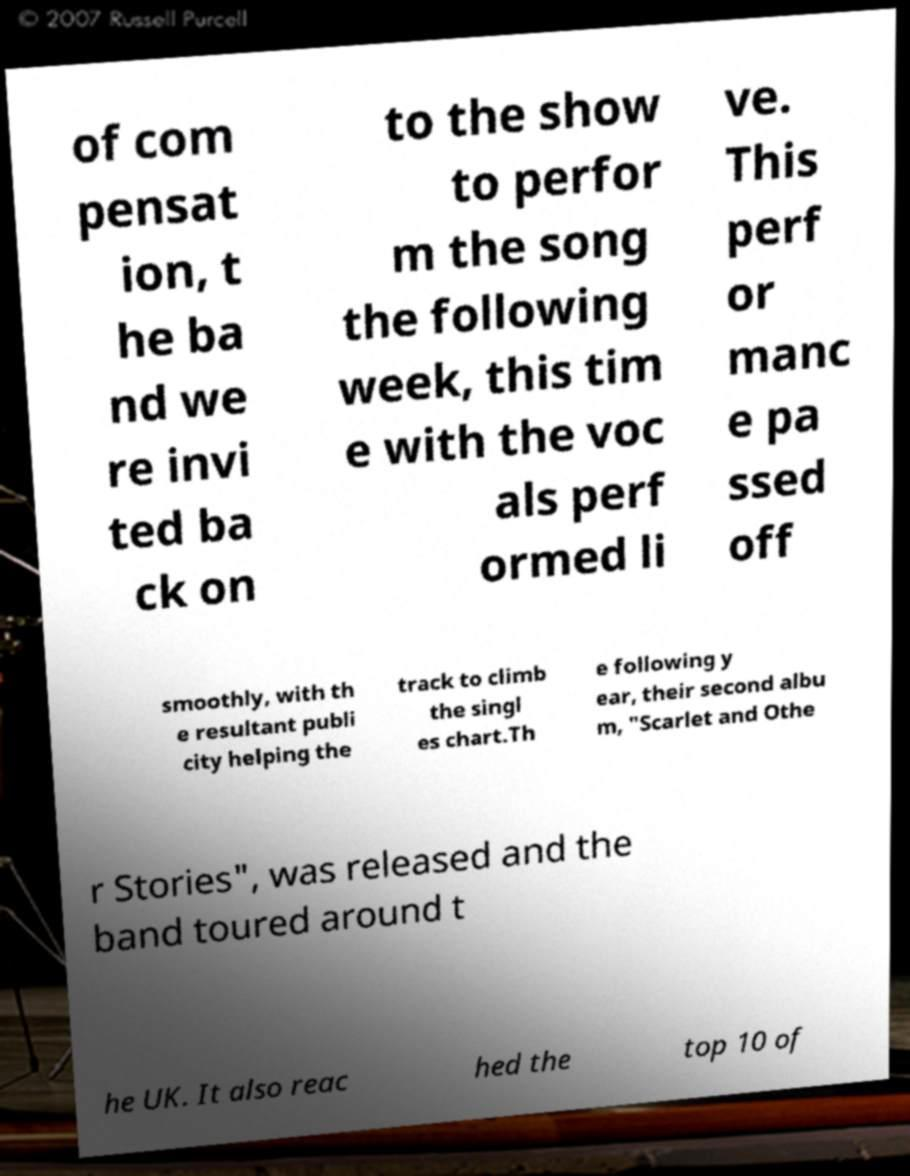For documentation purposes, I need the text within this image transcribed. Could you provide that? of com pensat ion, t he ba nd we re invi ted ba ck on to the show to perfor m the song the following week, this tim e with the voc als perf ormed li ve. This perf or manc e pa ssed off smoothly, with th e resultant publi city helping the track to climb the singl es chart.Th e following y ear, their second albu m, "Scarlet and Othe r Stories", was released and the band toured around t he UK. It also reac hed the top 10 of 